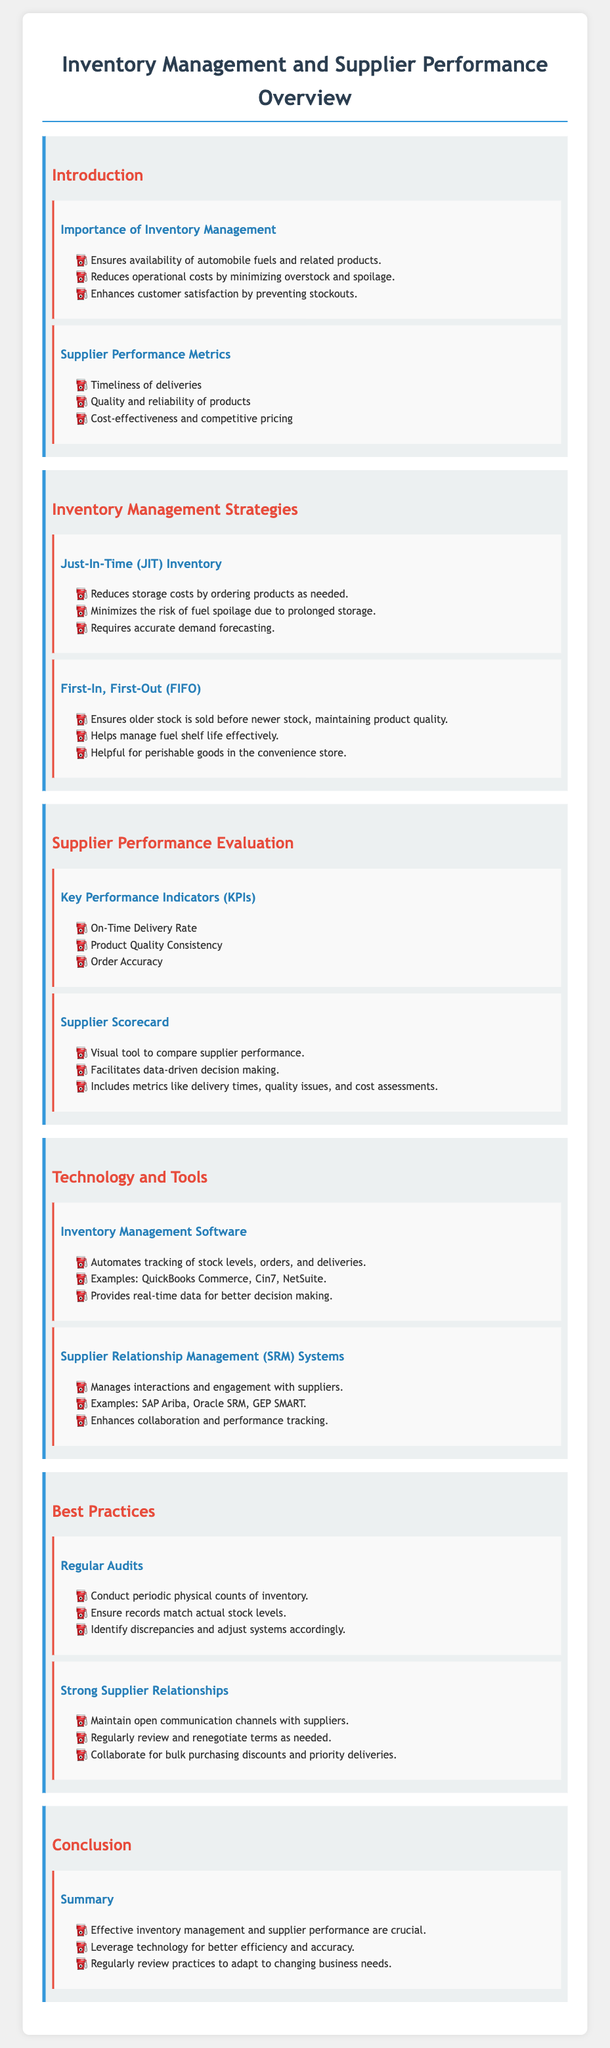What are the three key importance areas of inventory management? The document lists the importance of inventory management as ensuring availability of automobile fuels, reducing operational costs, and enhancing customer satisfaction.
Answer: Availability of automobile fuels, reducing operational costs, enhancing customer satisfaction What is the strategy that minimizes storage costs? The document refers to Just-In-Time (JIT) Inventory as the strategy that minimizes storage costs by ordering products as needed.
Answer: Just-In-Time (JIT) Inventory What does FIFO stand for? FIFO stands for First-In, First-Out, which ensures older stock is sold before newer stock.
Answer: First-In, First-Out Which key performance indicator emphasizes delivery timing? The On-Time Delivery Rate is the KPI that emphasizes delivery timing for evaluating supplier performance.
Answer: On-Time Delivery Rate Name one example of inventory management software mentioned. The document names QuickBooks Commerce as an example of inventory management software.
Answer: QuickBooks Commerce What is a visual tool used to compare supplier performance? The supplier scorecard is the visual tool mentioned for comparing supplier performance in the document.
Answer: Supplier Scorecard What metric assesses the consistency of supplier products? The document lists Product Quality Consistency as a metric to assess the consistency of supplier products.
Answer: Product Quality Consistency What is a best practice for inventory management mentioned in the document? Regular Audits are mentioned as a best practice for ensuring inventory accuracy.
Answer: Regular Audits What system enhances collaboration with suppliers? Supplier Relationship Management (SRM) Systems are mentioned as systems that enhance collaboration with suppliers.
Answer: Supplier Relationship Management (SRM) Systems 